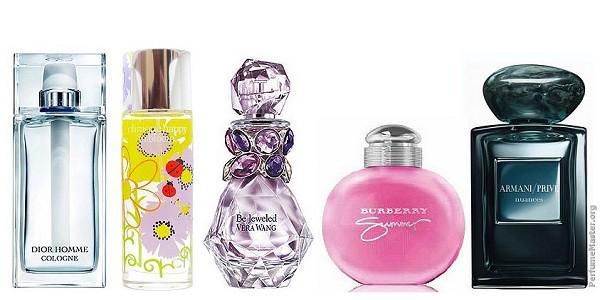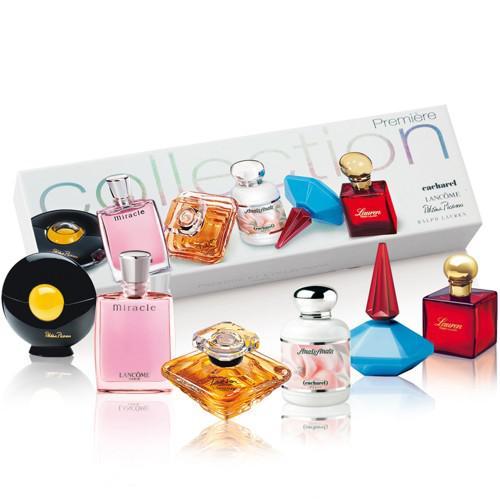The first image is the image on the left, the second image is the image on the right. Assess this claim about the two images: "The left image features a horizontal row of at least five different fragrance bottle shapes, while the right image shows at least one bottle in front of its box.". Correct or not? Answer yes or no. Yes. The first image is the image on the left, the second image is the image on the right. Given the left and right images, does the statement "There are six bottles grouped together in the image on the left." hold true? Answer yes or no. No. 